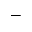Convert formula to latex. <formula><loc_0><loc_0><loc_500><loc_500>-</formula> 